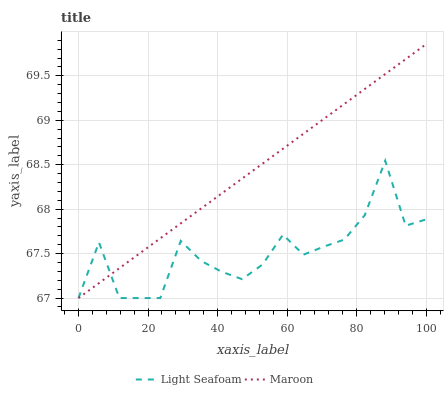Does Light Seafoam have the minimum area under the curve?
Answer yes or no. Yes. Does Maroon have the maximum area under the curve?
Answer yes or no. Yes. Does Maroon have the minimum area under the curve?
Answer yes or no. No. Is Maroon the smoothest?
Answer yes or no. Yes. Is Light Seafoam the roughest?
Answer yes or no. Yes. Is Maroon the roughest?
Answer yes or no. No. Does Light Seafoam have the lowest value?
Answer yes or no. Yes. Does Maroon have the highest value?
Answer yes or no. Yes. Does Maroon intersect Light Seafoam?
Answer yes or no. Yes. Is Maroon less than Light Seafoam?
Answer yes or no. No. Is Maroon greater than Light Seafoam?
Answer yes or no. No. 